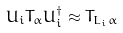Convert formula to latex. <formula><loc_0><loc_0><loc_500><loc_500>U _ { i } T _ { \alpha } U _ { i } ^ { \dag } \approx T _ { L _ { i } \alpha }</formula> 